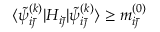<formula> <loc_0><loc_0><loc_500><loc_500>\langle \tilde { \psi } _ { i \bar { \jmath } } ^ { ( k ) } | H _ { i \bar { \jmath } } | \tilde { \psi } _ { i \bar { \jmath } } ^ { ( k ) } \rangle \geq m _ { i \bar { \jmath } } ^ { ( 0 ) }</formula> 